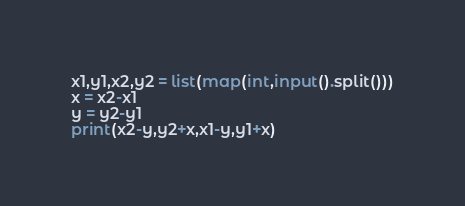Convert code to text. <code><loc_0><loc_0><loc_500><loc_500><_Python_>x1,y1,x2,y2 = list(map(int,input().split()))
x = x2-x1
y = y2-y1
print(x2-y,y2+x,x1-y,y1+x)
</code> 